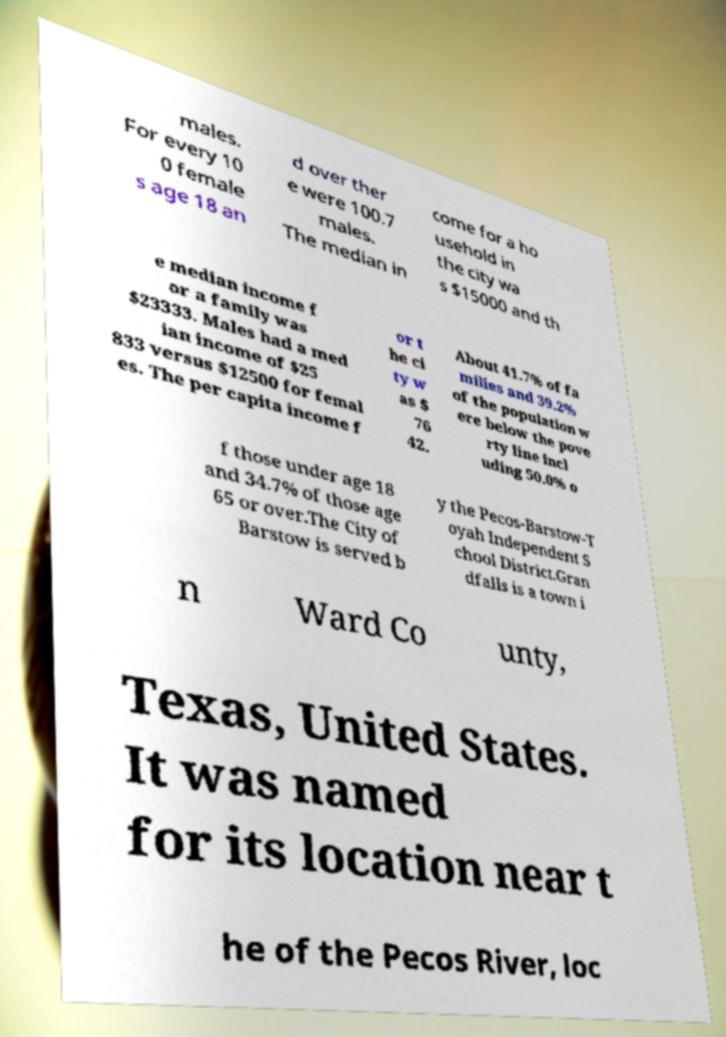Please identify and transcribe the text found in this image. males. For every 10 0 female s age 18 an d over ther e were 100.7 males. The median in come for a ho usehold in the city wa s $15000 and th e median income f or a family was $23333. Males had a med ian income of $25 833 versus $12500 for femal es. The per capita income f or t he ci ty w as $ 76 42. About 41.7% of fa milies and 39.2% of the population w ere below the pove rty line incl uding 50.0% o f those under age 18 and 34.7% of those age 65 or over.The City of Barstow is served b y the Pecos-Barstow-T oyah Independent S chool District.Gran dfalls is a town i n Ward Co unty, Texas, United States. It was named for its location near t he of the Pecos River, loc 